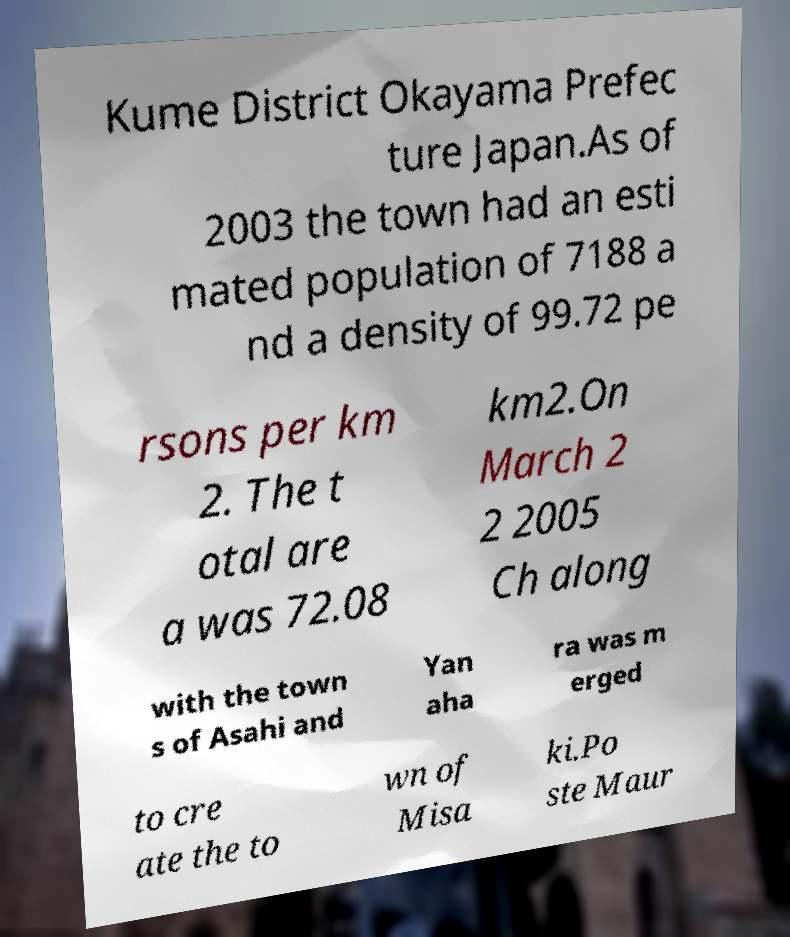Please read and relay the text visible in this image. What does it say? Kume District Okayama Prefec ture Japan.As of 2003 the town had an esti mated population of 7188 a nd a density of 99.72 pe rsons per km 2. The t otal are a was 72.08 km2.On March 2 2 2005 Ch along with the town s of Asahi and Yan aha ra was m erged to cre ate the to wn of Misa ki.Po ste Maur 